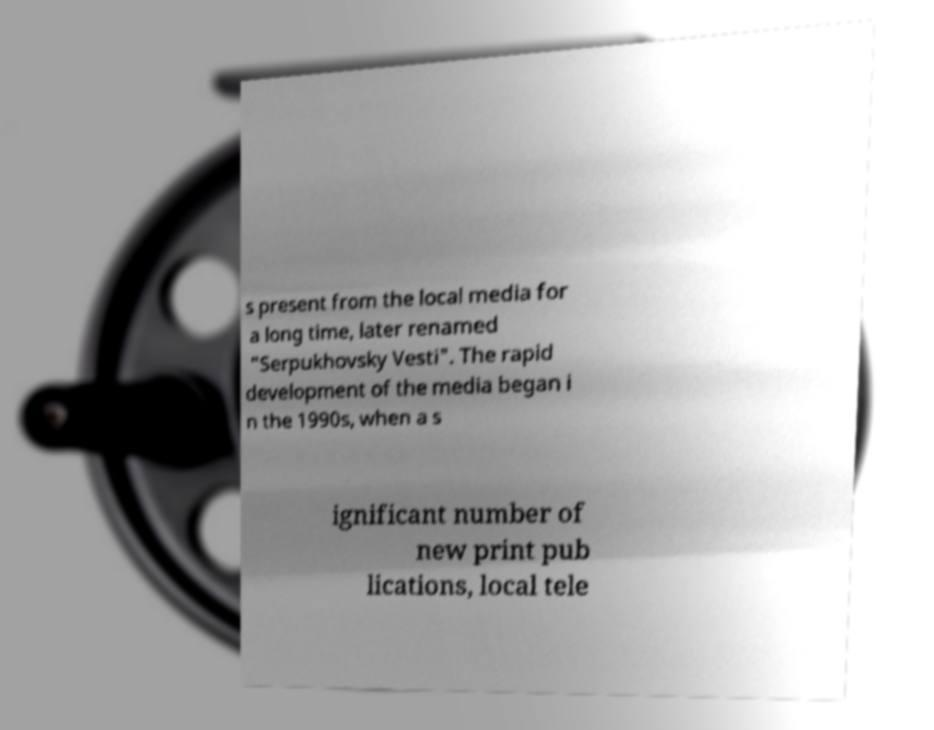I need the written content from this picture converted into text. Can you do that? s present from the local media for a long time, later renamed "Serpukhovsky Vesti". The rapid development of the media began i n the 1990s, when a s ignificant number of new print pub lications, local tele 